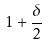Convert formula to latex. <formula><loc_0><loc_0><loc_500><loc_500>1 + \frac { \delta } { 2 }</formula> 